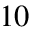Convert formula to latex. <formula><loc_0><loc_0><loc_500><loc_500>1 0</formula> 